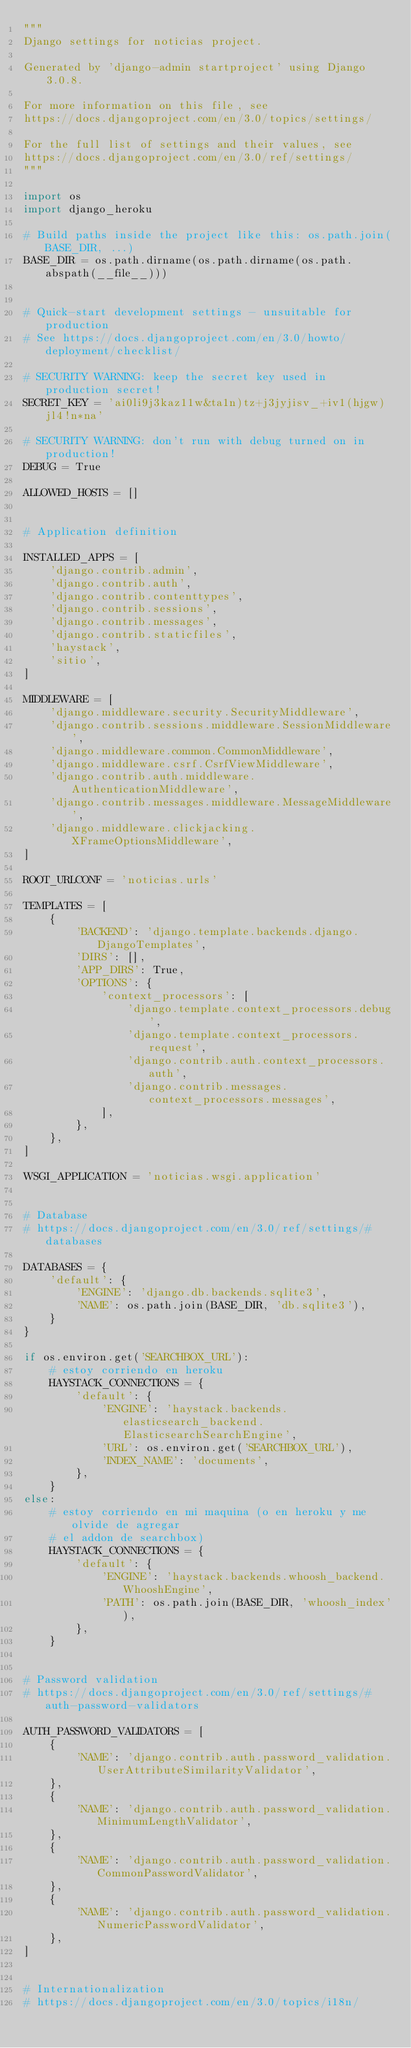Convert code to text. <code><loc_0><loc_0><loc_500><loc_500><_Python_>"""
Django settings for noticias project.

Generated by 'django-admin startproject' using Django 3.0.8.

For more information on this file, see
https://docs.djangoproject.com/en/3.0/topics/settings/

For the full list of settings and their values, see
https://docs.djangoproject.com/en/3.0/ref/settings/
"""

import os
import django_heroku

# Build paths inside the project like this: os.path.join(BASE_DIR, ...)
BASE_DIR = os.path.dirname(os.path.dirname(os.path.abspath(__file__)))


# Quick-start development settings - unsuitable for production
# See https://docs.djangoproject.com/en/3.0/howto/deployment/checklist/

# SECURITY WARNING: keep the secret key used in production secret!
SECRET_KEY = 'ai0li9j3kaz11w&ta1n)tz+j3jyjisv_+iv1(hjgw)jl4!n*na'

# SECURITY WARNING: don't run with debug turned on in production!
DEBUG = True

ALLOWED_HOSTS = []


# Application definition

INSTALLED_APPS = [
    'django.contrib.admin',
    'django.contrib.auth',
    'django.contrib.contenttypes',
    'django.contrib.sessions',
    'django.contrib.messages',
    'django.contrib.staticfiles',
    'haystack',
    'sitio',
]

MIDDLEWARE = [
    'django.middleware.security.SecurityMiddleware',
    'django.contrib.sessions.middleware.SessionMiddleware',
    'django.middleware.common.CommonMiddleware',
    'django.middleware.csrf.CsrfViewMiddleware',
    'django.contrib.auth.middleware.AuthenticationMiddleware',
    'django.contrib.messages.middleware.MessageMiddleware',
    'django.middleware.clickjacking.XFrameOptionsMiddleware',
]

ROOT_URLCONF = 'noticias.urls'

TEMPLATES = [
    {
        'BACKEND': 'django.template.backends.django.DjangoTemplates',
        'DIRS': [],
        'APP_DIRS': True,
        'OPTIONS': {
            'context_processors': [
                'django.template.context_processors.debug',
                'django.template.context_processors.request',
                'django.contrib.auth.context_processors.auth',
                'django.contrib.messages.context_processors.messages',
            ],
        },
    },
]

WSGI_APPLICATION = 'noticias.wsgi.application'


# Database
# https://docs.djangoproject.com/en/3.0/ref/settings/#databases

DATABASES = {
    'default': {
        'ENGINE': 'django.db.backends.sqlite3',
        'NAME': os.path.join(BASE_DIR, 'db.sqlite3'),
    }
}

if os.environ.get('SEARCHBOX_URL'):
    # estoy corriendo en heroku
    HAYSTACK_CONNECTIONS = {
        'default': {
            'ENGINE': 'haystack.backends.elasticsearch_backend.ElasticsearchSearchEngine',
            'URL': os.environ.get('SEARCHBOX_URL'),
            'INDEX_NAME': 'documents',
        },
    }
else:
    # estoy corriendo en mi maquina (o en heroku y me olvide de agregar
    # el addon de searchbox)
    HAYSTACK_CONNECTIONS = {
        'default': {
            'ENGINE': 'haystack.backends.whoosh_backend.WhooshEngine',
            'PATH': os.path.join(BASE_DIR, 'whoosh_index'),
        },
    }


# Password validation
# https://docs.djangoproject.com/en/3.0/ref/settings/#auth-password-validators

AUTH_PASSWORD_VALIDATORS = [
    {
        'NAME': 'django.contrib.auth.password_validation.UserAttributeSimilarityValidator',
    },
    {
        'NAME': 'django.contrib.auth.password_validation.MinimumLengthValidator',
    },
    {
        'NAME': 'django.contrib.auth.password_validation.CommonPasswordValidator',
    },
    {
        'NAME': 'django.contrib.auth.password_validation.NumericPasswordValidator',
    },
]


# Internationalization
# https://docs.djangoproject.com/en/3.0/topics/i18n/
</code> 